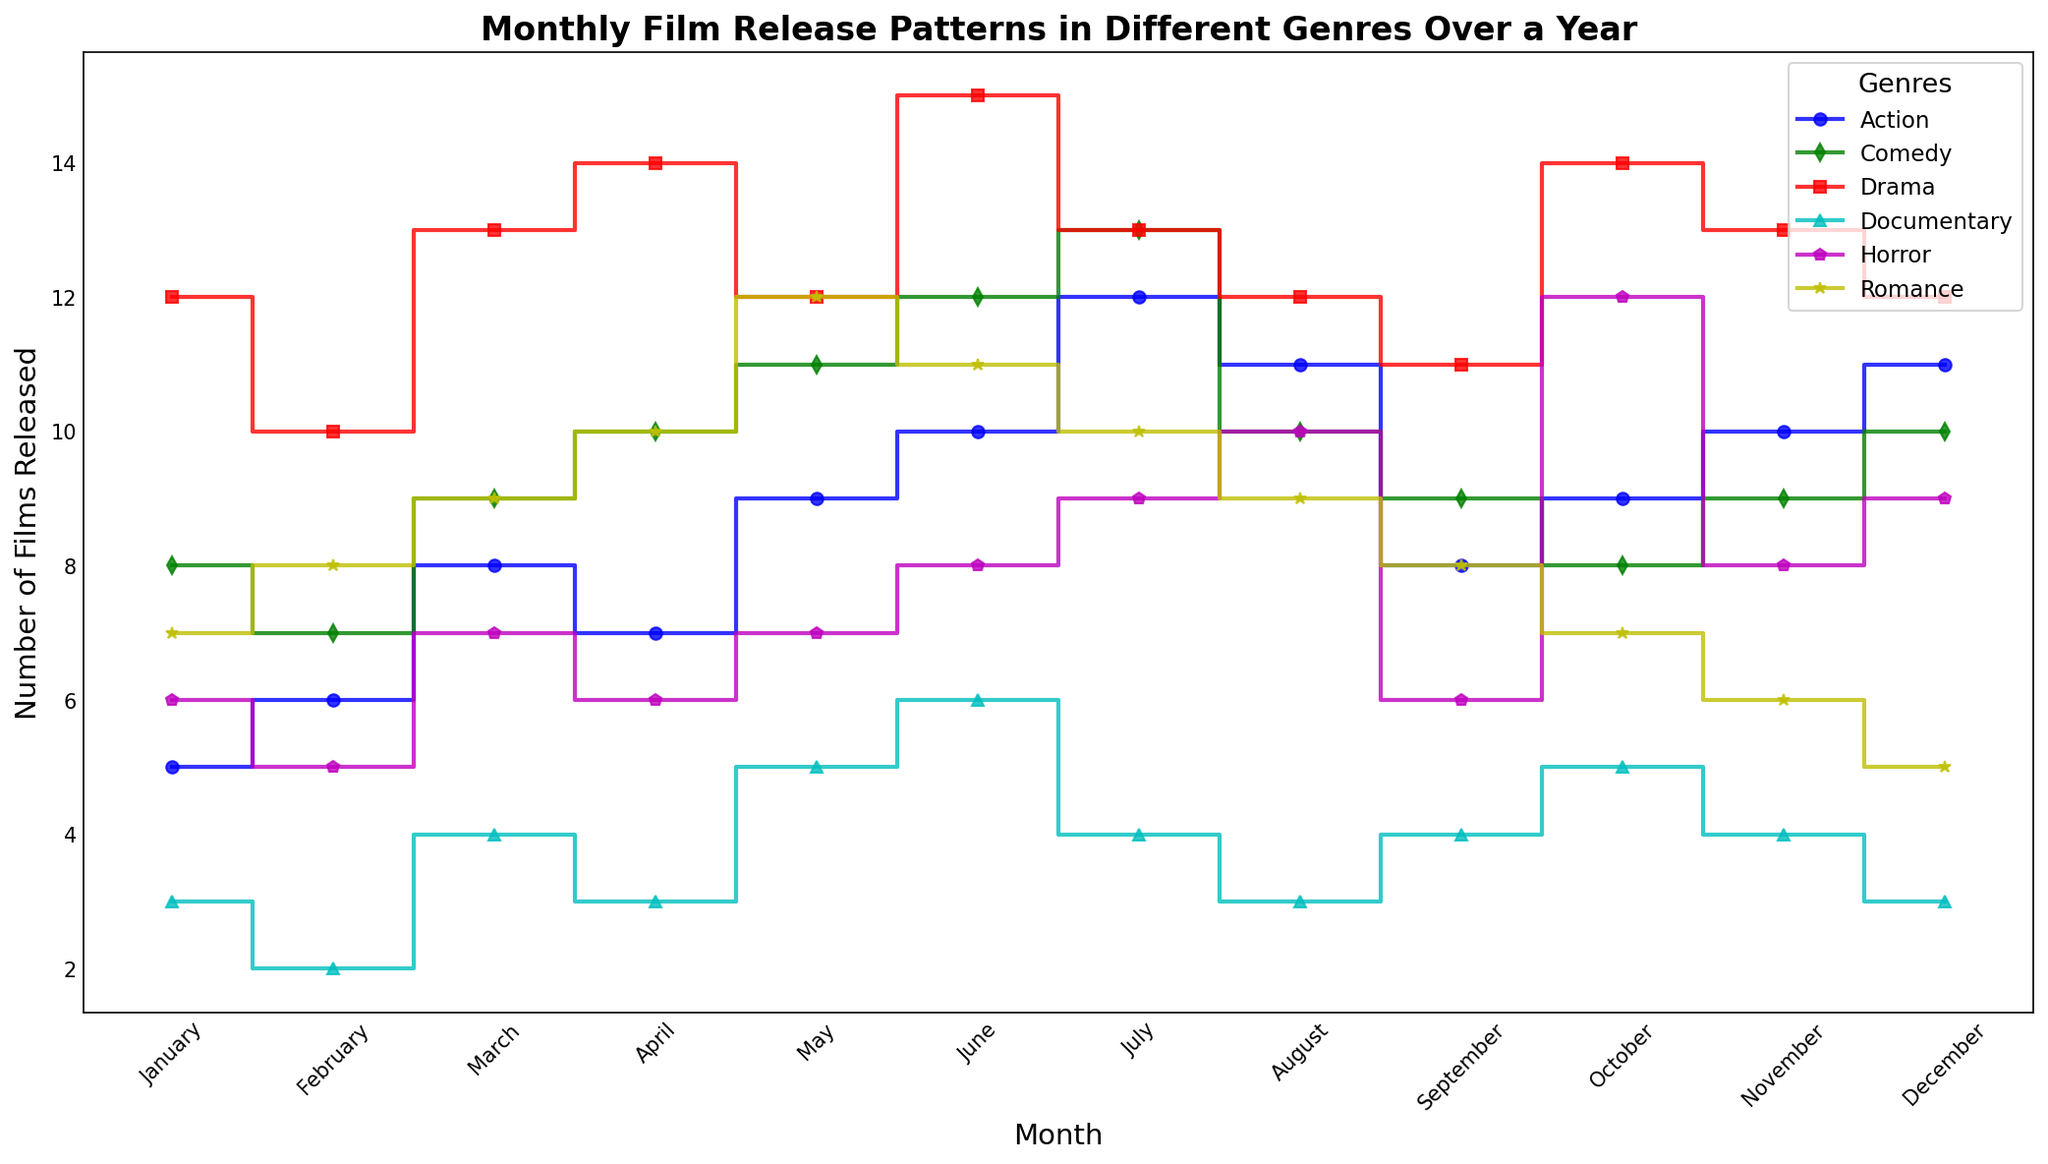Which genre had the highest number of releases in June? To determine this, look at the step plot for June and observe the highest point corresponding to a genre. The Drama genre reaches a peak of 15 films in June, which is higher than the other genres.
Answer: Drama How many more Action films were released in July compared to January? First, find the number of Action films released in January, which is 5, and in July, which is 12. Then, subtract the January number from the July number (12 - 5).
Answer: 7 Which month had the lowest number of Documentary releases, and what was that number? Locate the Documentary plot line and identify the minimum point on the y-axis. February shows the lowest number of Documentary films at 2.
Answer: February, 2 What is the average number of Romance films released over the year? Sum all monthly Romance release numbers (7+8+9+10+12+11+10+9+8+7+6+5 = 102) and divide by 12 months.
Answer: 8.5 In which month did Comedy films have the same number of releases as Horror films, if any? Compare the step plots of Comedy and Horror month by month. Both genres had 10 releases in June.
Answer: June Between which two consecutive months did the Horror genre see the highest increase in film releases? Examine the Horror plot line to spot the steepest increase. From September (6 films) to October (12 films), there is an increase of 6 films, which is the highest.
Answer: September to October What is the total number of Drama and Romance film releases in December? Find the releases in December for Drama (12) and Romance (5), then sum them (12 + 5).
Answer: 17 Is there any month where the number of Documentary releases equals the number of Action releases? Compare the Documentary and Action step plots month by month. Both genres had 3 releases in January.
Answer: January Which genre fluctuates the most in terms of releases throughout the year? Observe the y-axis fluctuations for each genre. Documentary films show the most fluctuation because their releases vary significantly from month to month, often swinging between the high and low numbers.
Answer: Documentary 